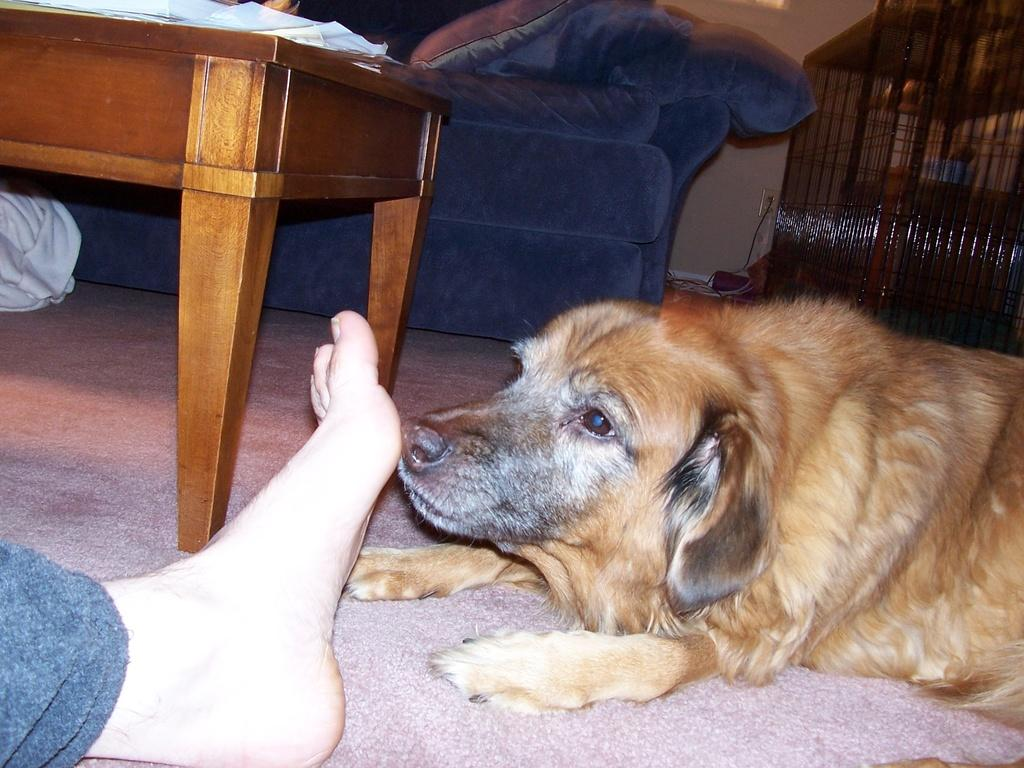What animal is present in the image? There is a dog in the image. What is the dog doing in the image? The dog is sniffing a human leg. Where is the dog located in the image? The dog is on the floor. What furniture is visible in the image? There is a table and a sofa in the image. What type of bear can be seen sitting on the sofa in the image? There is no bear present in the image; it features a dog sniffing a human leg on the floor. How many tickets are visible on the table in the image? There are no tickets visible on the table in the image. 